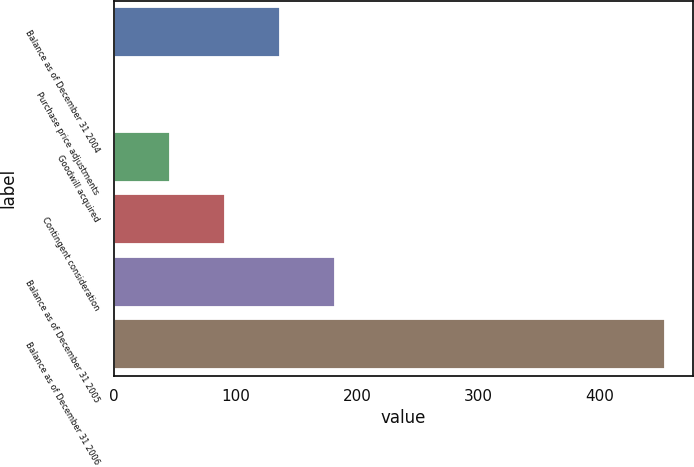<chart> <loc_0><loc_0><loc_500><loc_500><bar_chart><fcel>Balance as of December 31 2004<fcel>Purchase price adjustments<fcel>Goodwill acquired<fcel>Contingent consideration<fcel>Balance as of December 31 2005<fcel>Balance as of December 31 2006<nl><fcel>136.9<fcel>1<fcel>46.3<fcel>91.6<fcel>182.2<fcel>454<nl></chart> 